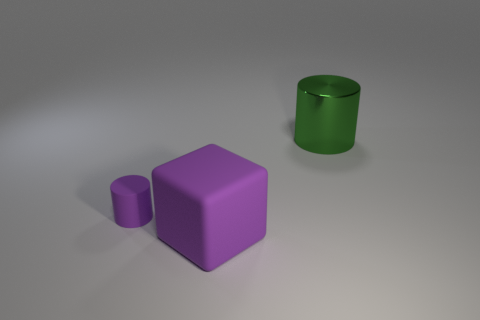Can you hypothesize a context or setting for these objects? Considering the simplicity and isolated placement of the objects, they could be part of a 3D modeling or rendering tutorial where the focus is on learning about shapes, materials, and lighting without the distraction of a complex environment. 